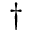Convert formula to latex. <formula><loc_0><loc_0><loc_500><loc_500>^ { \dagger }</formula> 